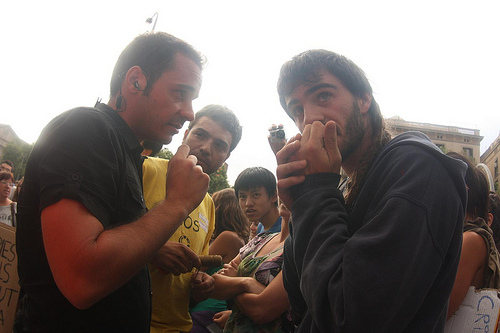<image>
Can you confirm if the earpiece is on the man? No. The earpiece is not positioned on the man. They may be near each other, but the earpiece is not supported by or resting on top of the man. 